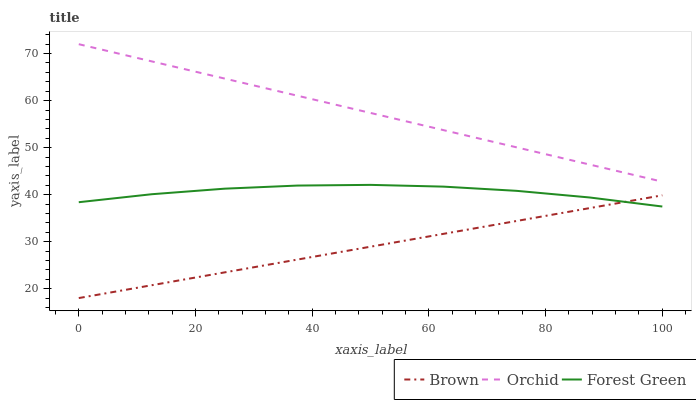Does Forest Green have the minimum area under the curve?
Answer yes or no. No. Does Forest Green have the maximum area under the curve?
Answer yes or no. No. Is Orchid the smoothest?
Answer yes or no. No. Is Orchid the roughest?
Answer yes or no. No. Does Forest Green have the lowest value?
Answer yes or no. No. Does Forest Green have the highest value?
Answer yes or no. No. Is Forest Green less than Orchid?
Answer yes or no. Yes. Is Orchid greater than Forest Green?
Answer yes or no. Yes. Does Forest Green intersect Orchid?
Answer yes or no. No. 